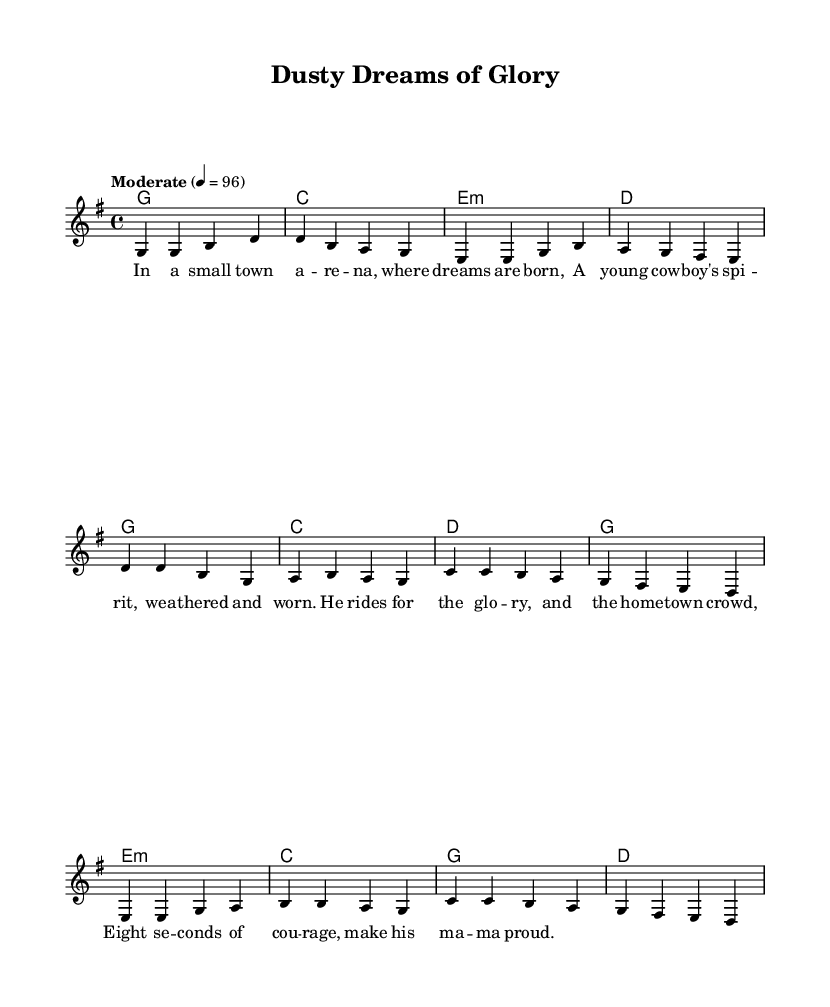What is the key signature of this music? The key signature is indicated by the presence of one sharp, which corresponds to G major.
Answer: G major What is the time signature of this music? The time signature appears at the beginning of the staff, showing it is in 4/4 time, meaning there are four beats per measure.
Answer: 4/4 What is the tempo marking for this piece? The tempo is indicated as "Moderate" with a metronome marking of 96 beats per minute, providing guidance on the speed of the piece.
Answer: Moderate 4 = 96 How many measures are in the verse? Counting the measures in the verse section, there are four measures present, each corresponding to the lyrics and melody described.
Answer: 4 What chord is played during the chorus on the first measure? Looking at the chord symbols above the melody in the chorus, the first chord is G major, indicated by the letter 'g'.
Answer: G Which element describes the main theme of this piece? The lyrics and melody, focusing on the narrative of a young cowboy's struggle and aspirations, exemplify common themes in Americana storytelling music.
Answer: Cowboy dreams What is the primary mood conveyed in the lyrics of the verse? The lyrics reflect a sense of pride and determination from the young cowboy perspective, capturing an uplifting sentiment typical of small-town Americana.
Answer: Pride 